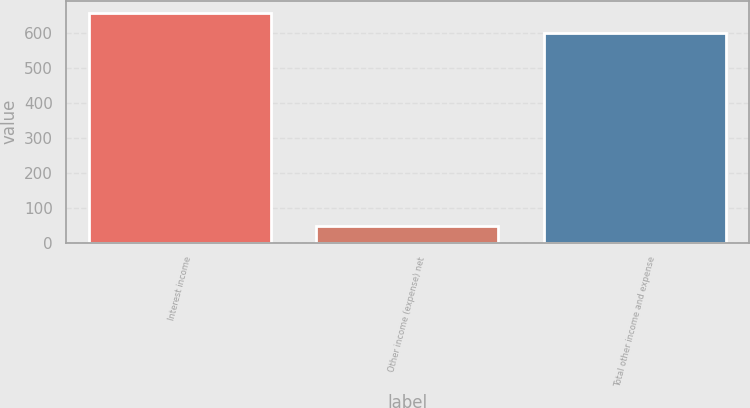Convert chart to OTSL. <chart><loc_0><loc_0><loc_500><loc_500><bar_chart><fcel>Interest income<fcel>Other income (expense) net<fcel>Total other income and expense<nl><fcel>658.9<fcel>48<fcel>599<nl></chart> 